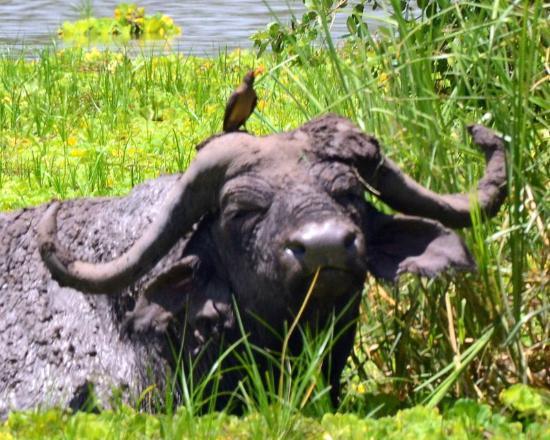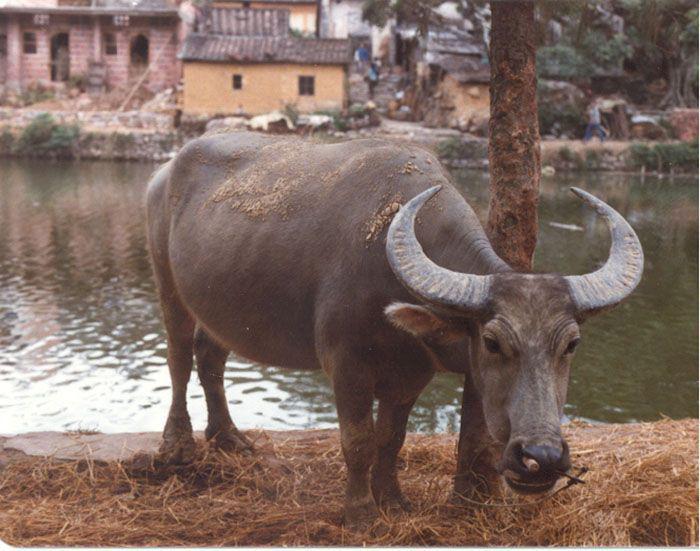The first image is the image on the left, the second image is the image on the right. Examine the images to the left and right. Is the description "The animal in the image on the right is standing in side profile with its head turned toward the camera." accurate? Answer yes or no. No. 